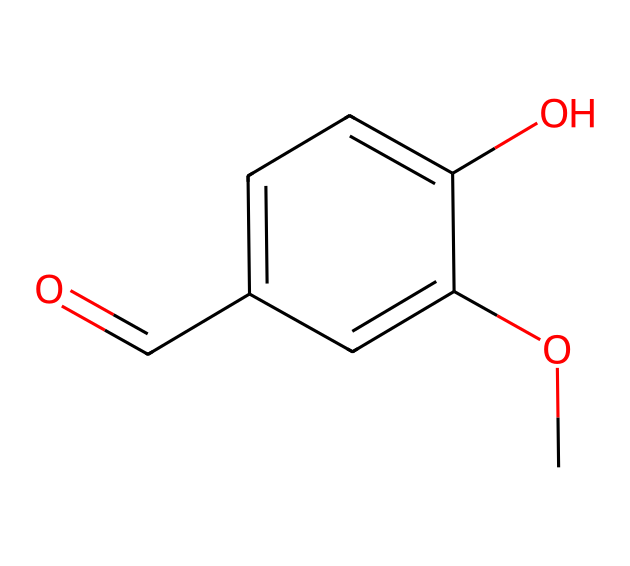What is the molecular formula of this compound? The SMILES representation indicates the number of each type of atom present. Counting oxygen (O), carbon (C), and hydrogen (H) atoms in the structure, we find 8 carbons, 8 hydrogens, and 3 oxygens, which gives the molecular formula C8H8O3.
Answer: C8H8O3 How many hydroxyl groups are present in this molecule? By analyzing the structure from the SMILES, we observe that there is one -OH group attached to the aromatic ring, indicating that there is one hydroxyl group.
Answer: one What functional groups are evident in this compound? The SMILES shows a carbonyl group (C=O) characteristic of aldehydes and a hydroxyl group (-OH). These functional groups are key features of the molecule's structure.
Answer: aldehyde and hydroxyl What type of aromatic compound is represented here? The presence of a benzene ring in the structure implies that this chemical is classified as a phenolic compound, specifically due to the additional -OH group on the aromatic ring.
Answer: phenolic Why is vanillin classified as an aldehyde? The structure contains a functional carbonyl group (C=O) at the end of the carbon chain, which is characteristic of aldehydes. This identification is critical to its classification.
Answer: carbonyl at the end How does the presence of the methoxy group influence the compound? The methoxy group (-OCH3) attached to the aromatic ring affects the compound's aroma and enhances its sweetness. It contributes to the overall flavor profile of vanillin, making it more desirable in air fresheners.
Answer: enhances aroma What is the significance of the carbonyl position in this molecule? The carbonyl position indicates that this is an aldehyde, which typically makes the compound more reactive than ketones or other compounds due to the carbon's location and bonding.
Answer: indicates reactivity 